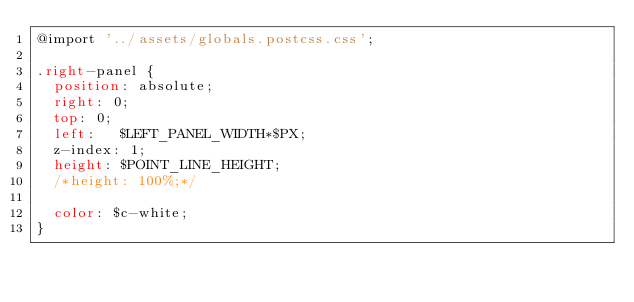<code> <loc_0><loc_0><loc_500><loc_500><_CSS_>@import '../assets/globals.postcss.css';

.right-panel {
  position: absolute;
  right: 0;
  top: 0;
  left:   $LEFT_PANEL_WIDTH*$PX;
  z-index: 1;
  height: $POINT_LINE_HEIGHT;
  /*height: 100%;*/

  color: $c-white;
}
</code> 